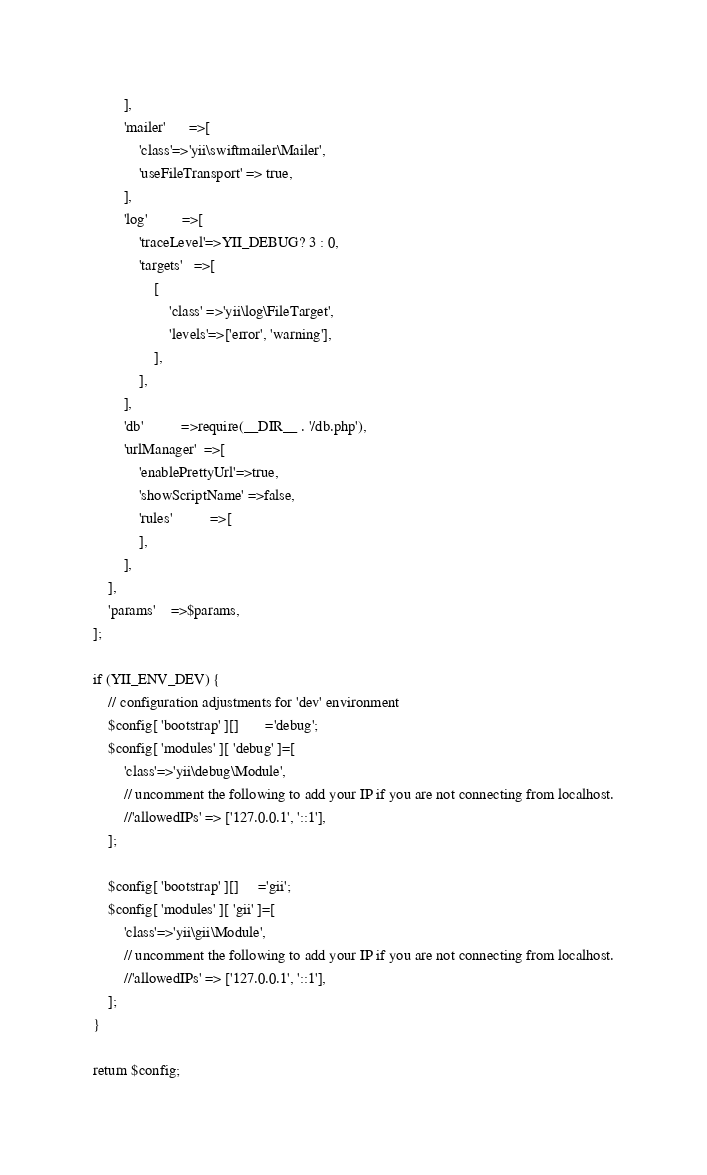<code> <loc_0><loc_0><loc_500><loc_500><_PHP_>        ],
        'mailer'      =>[
            'class'=>'yii\swiftmailer\Mailer',
            'useFileTransport' => true,
        ],
        'log'         =>[
            'traceLevel'=>YII_DEBUG? 3 : 0,
            'targets'   =>[
                [
                    'class' =>'yii\log\FileTarget',
                    'levels'=>['error', 'warning'],
                ],
            ],
        ],
        'db'          =>require(__DIR__ . '/db.php'),
        'urlManager'  =>[
            'enablePrettyUrl'=>true,
            'showScriptName' =>false,
            'rules'          =>[
            ],
        ],
    ],
    'params'    =>$params,
];

if (YII_ENV_DEV) {
    // configuration adjustments for 'dev' environment
    $config[ 'bootstrap' ][]       ='debug';
    $config[ 'modules' ][ 'debug' ]=[
        'class'=>'yii\debug\Module',
        // uncomment the following to add your IP if you are not connecting from localhost.
        //'allowedIPs' => ['127.0.0.1', '::1'],
    ];

    $config[ 'bootstrap' ][]     ='gii';
    $config[ 'modules' ][ 'gii' ]=[
        'class'=>'yii\gii\Module',
        // uncomment the following to add your IP if you are not connecting from localhost.
        //'allowedIPs' => ['127.0.0.1', '::1'],
    ];
}

return $config;
</code> 